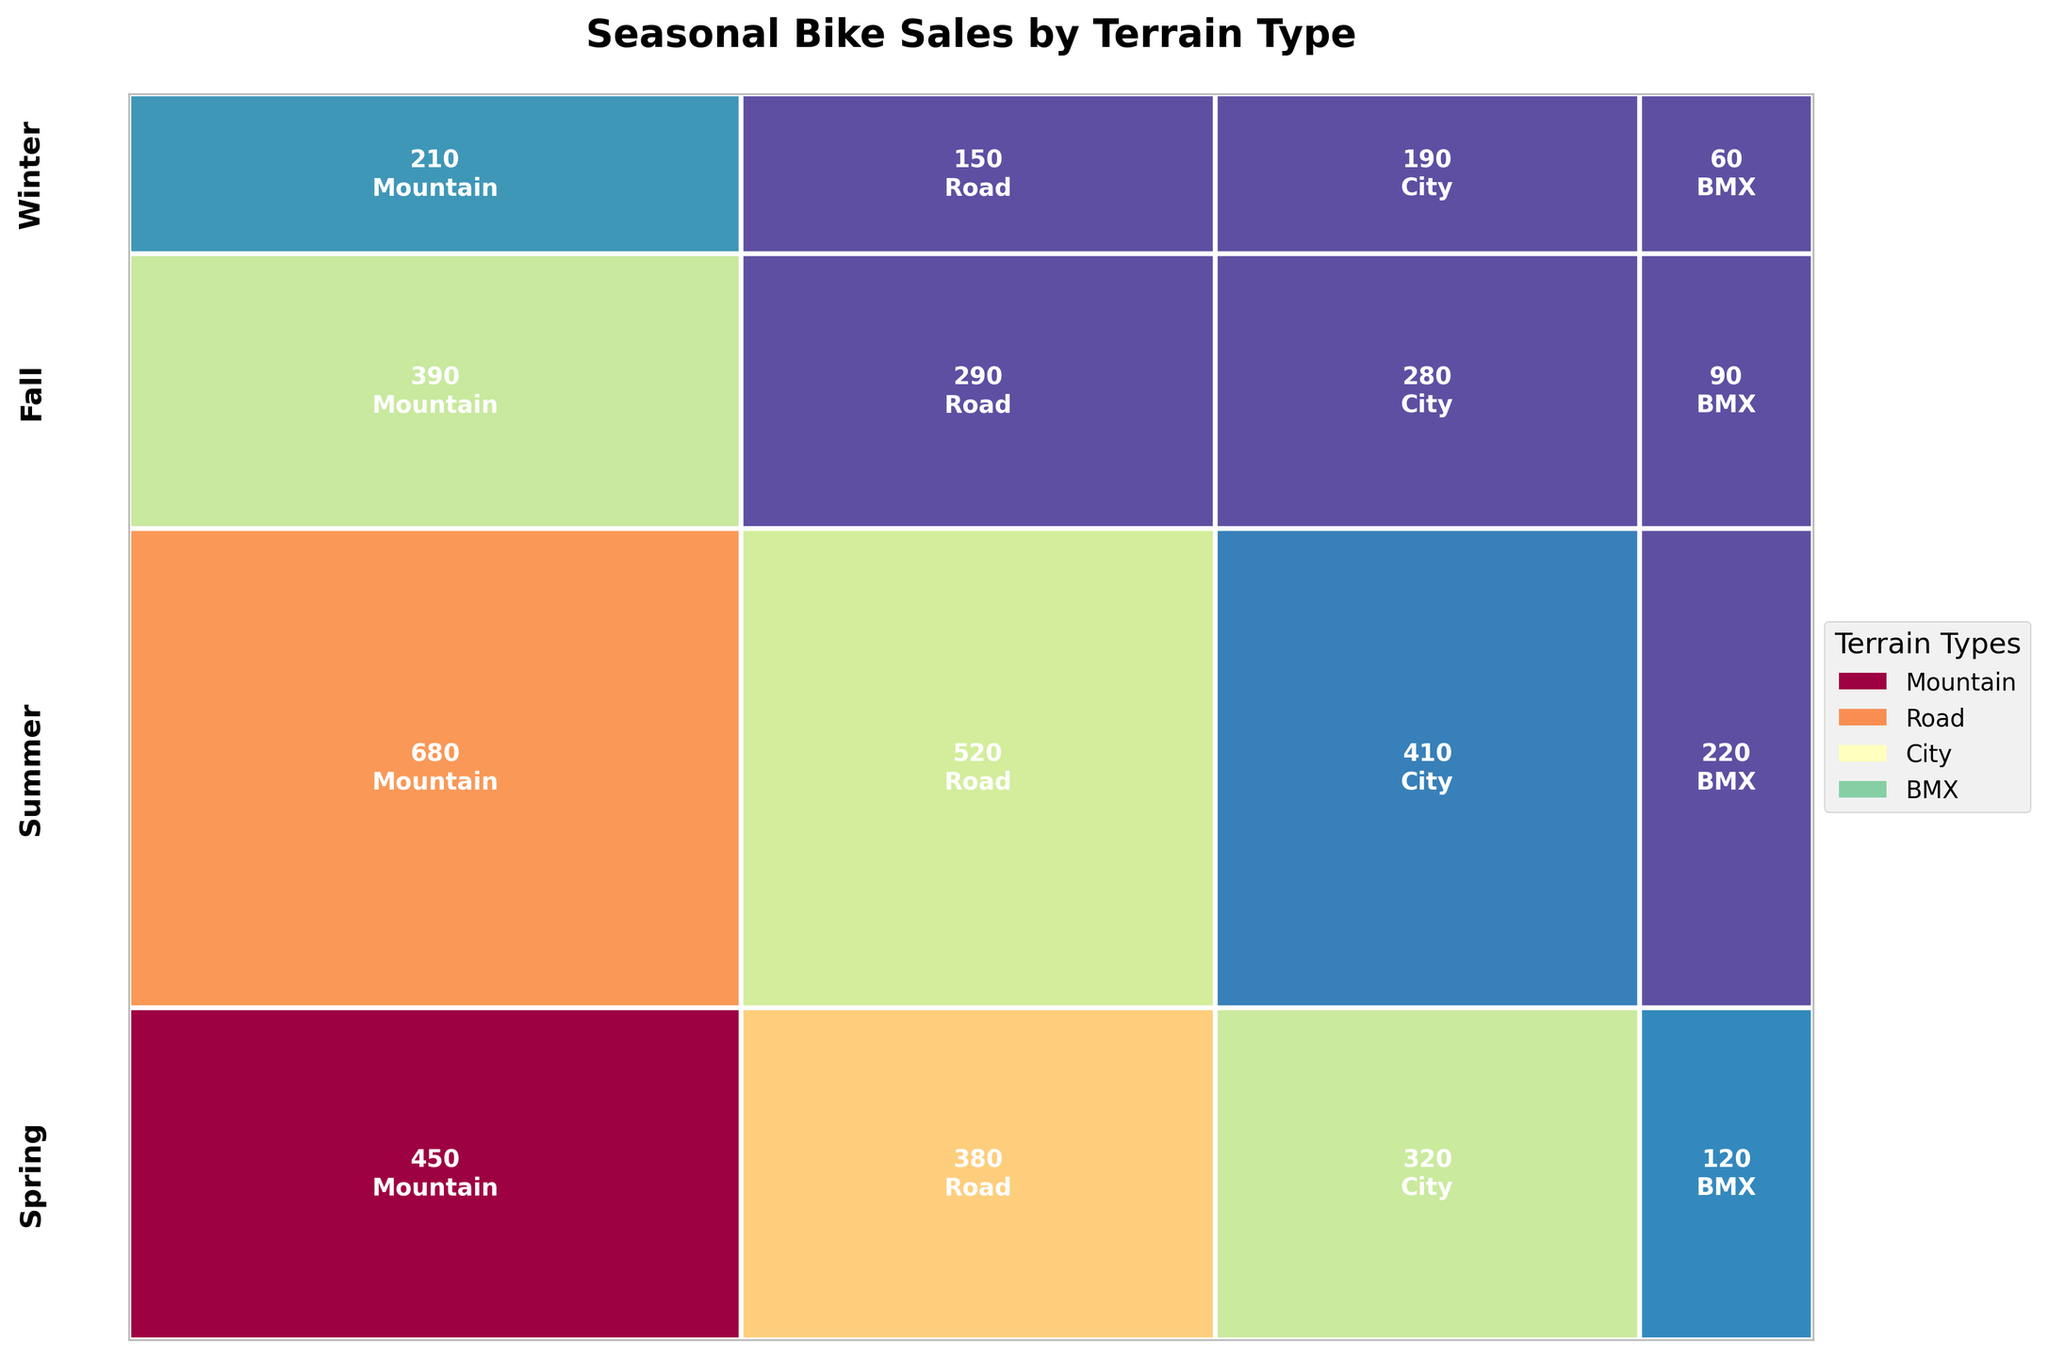Which season has the highest overall bike sales? To find the season with the highest overall bike sales, look at the height of the sections for each season. The highest section indicates the season with the highest sales. The tallest section corresponds to Summer.
Answer: Summer What type of terrain has the most sales during Spring? Focus on the Spring section (look for the label "Spring" on the y-axis) and compare the widths of the rectangles. The widest rectangle within Spring indicates the terrain type with the most sales, which is Mountain.
Answer: Mountain Which terrain has the lowest sales in Winter? Locate the Winter section and look for the narrowest rectangle. This represents the terrain type with the lowest sales, which is BMX.
Answer: BMX By how much do Mountain bike sales in Summer exceed those in Winter? Identify the Mountain sales for both Summer and Winter from the plot. For Summer, Mountain bike sales are 680, and for Winter, they are 210. Subtract Winter sales from Summer sales: 680 - 210.
Answer: 470 Which terrain sees the smallest seasonal variation in sales? To determine the terrain with the smallest seasonal variation, look for the terrain type that has the most consistent width across all seasons. City bikes appear to have the most consistent width.
Answer: City Which season has the least sales for Road bikes? Find the sections labeled with each season and identify which one has the narrowest rectangle for Road bikes. The narrowest one is in Winter.
Answer: Winter What is the total sales for BMX bikes in Summer and Fall combined? Identify the sales for BMX bikes during Summer and Fall. Summer sales are 220, and Fall sales are 90. Sum the two values: 220 + 90.
Answer: 310 Is the proportion of Road bike sales higher in Spring or Fall? Compare the widths of the rectangles for Road bikes in Spring and Fall. The wider rectangle indicates a higher proportion of sales. Road bike sales appear wider in Spring than in Fall.
Answer: Spring How do total sales in Winter compare to those in Fall? Compare the heights of the sections for Winter and Fall. The Winter section is shorter than the Fall section, indicating fewer total sales in Winter compared to Fall.
Answer: Lower What is the ratio of Mountain bike sales in Summer to those in Spring? Identify sales figures for Mountain bikes in Summer (680) and Spring (450). Divide Summer sales by Spring sales: 680 / 450.
Answer: 1.51 